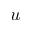<formula> <loc_0><loc_0><loc_500><loc_500>u</formula> 